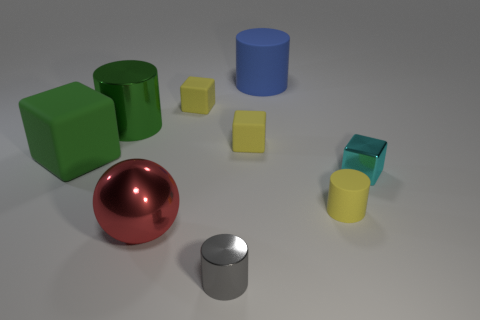There is a big object that is the same color as the big block; what material is it?
Make the answer very short. Metal. Are there any red metallic spheres that have the same size as the cyan cube?
Give a very brief answer. No. Are there more small gray shiny cylinders that are on the left side of the big sphere than matte objects that are behind the tiny gray metal cylinder?
Provide a succinct answer. No. Is the tiny cylinder that is to the right of the big blue cylinder made of the same material as the thing that is in front of the big red ball?
Ensure brevity in your answer.  No. What shape is the blue matte object that is the same size as the red shiny ball?
Your answer should be compact. Cylinder. Is there a small matte object that has the same shape as the green metallic object?
Make the answer very short. Yes. There is a tiny rubber thing that is to the right of the blue object; does it have the same color as the metallic cylinder that is to the right of the big green cylinder?
Make the answer very short. No. Are there any big red shiny things behind the large green metal thing?
Offer a very short reply. No. What is the tiny object that is both in front of the tiny cyan thing and left of the blue matte cylinder made of?
Provide a succinct answer. Metal. Does the tiny yellow thing in front of the cyan shiny block have the same material as the cyan thing?
Your answer should be compact. No. 